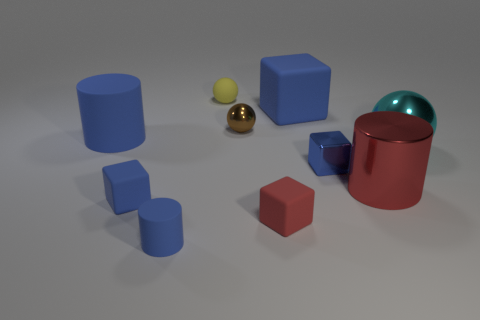Subtract all gray cylinders. How many blue blocks are left? 3 Subtract 1 blocks. How many blocks are left? 3 Subtract all balls. How many objects are left? 7 Add 5 large cyan shiny spheres. How many large cyan shiny spheres are left? 6 Add 1 small red things. How many small red things exist? 2 Subtract 1 cyan spheres. How many objects are left? 9 Subtract all tiny spheres. Subtract all red metallic cylinders. How many objects are left? 7 